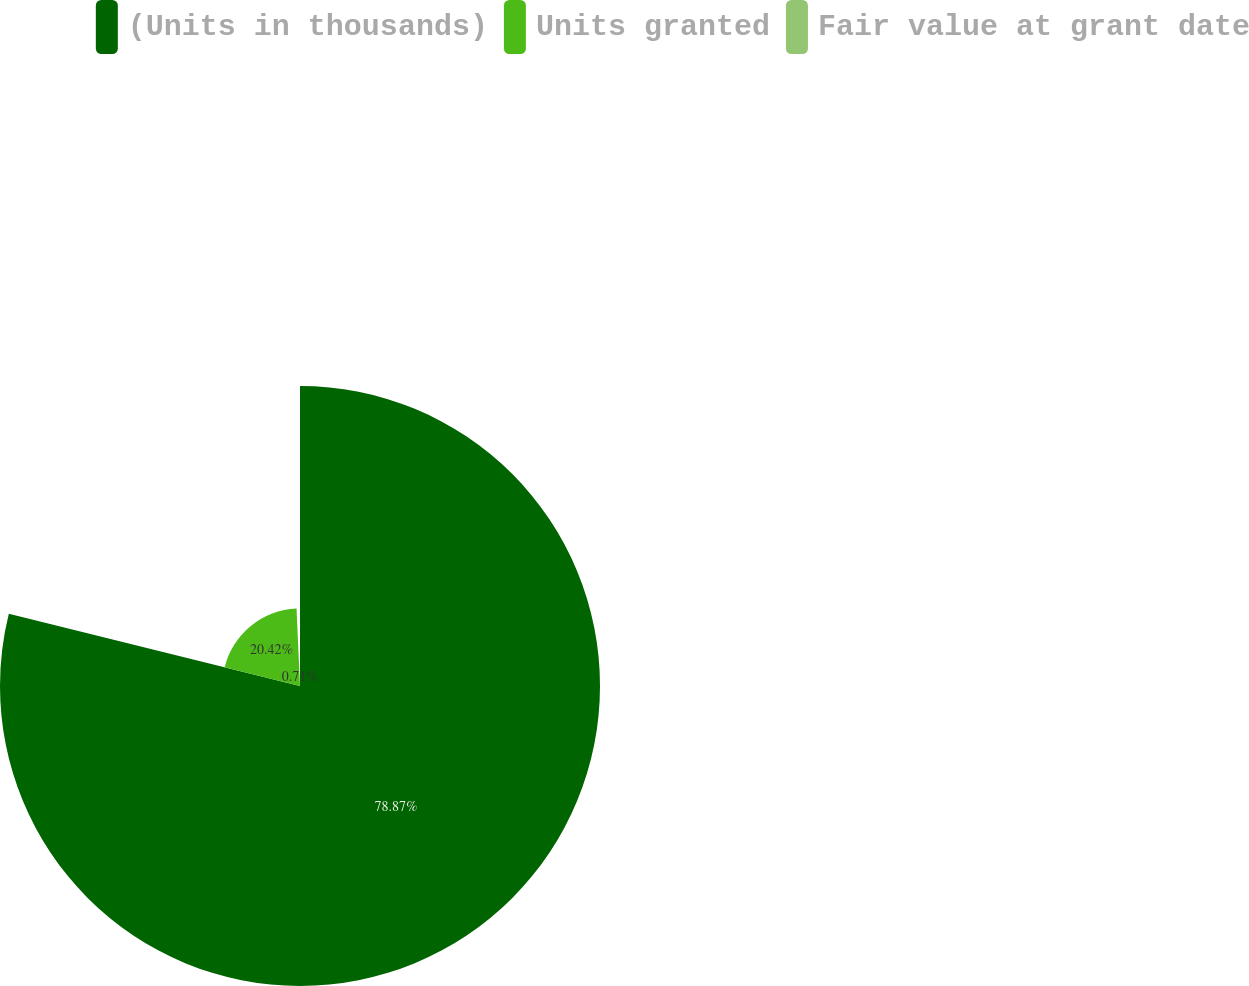Convert chart to OTSL. <chart><loc_0><loc_0><loc_500><loc_500><pie_chart><fcel>(Units in thousands)<fcel>Units granted<fcel>Fair value at grant date<nl><fcel>78.87%<fcel>20.42%<fcel>0.71%<nl></chart> 